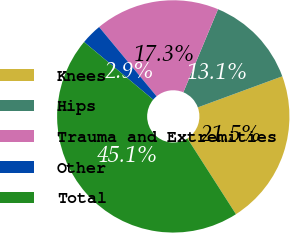<chart> <loc_0><loc_0><loc_500><loc_500><pie_chart><fcel>Knees<fcel>Hips<fcel>Trauma and Extremities<fcel>Other<fcel>Total<nl><fcel>21.54%<fcel>13.1%<fcel>17.32%<fcel>2.91%<fcel>45.14%<nl></chart> 